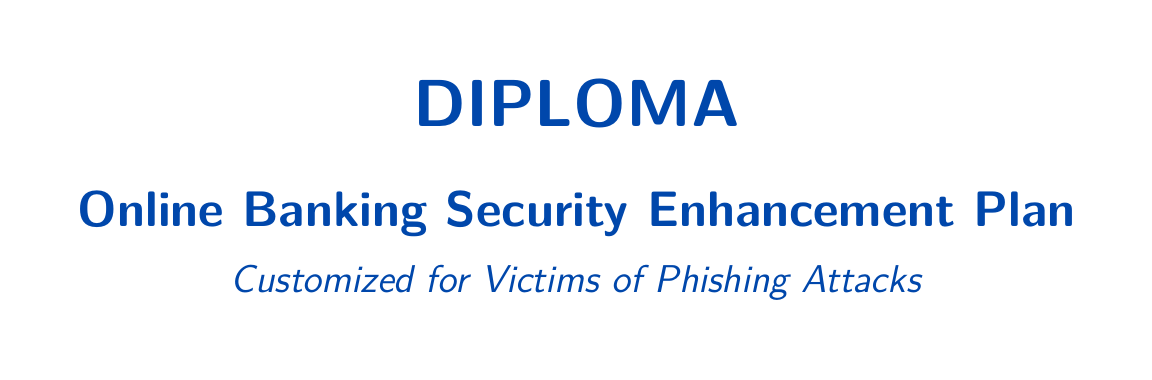What is the title of the document? The title of the document is stated at the top and identifies the content focus.
Answer: Online Banking Security Enhancement Plan What should you do immediately after a phishing incident? The document includes a specific section detailing immediate steps to take post-incident.
Answer: Change your online banking passwords What is one action you can take to enhance online banking security? The document lists several actionable steps to improve security for online banking accounts.
Answer: Enable Two-Factor Authentication (2FA) How often should you monitor your account activity? The document mentions the importance of frequent reviews to detect suspicious transactions.
Answer: Regularly What type of software should you install for protection? The document recommends specific tools to enhance security against potential threats.
Answer: Anti-virus and Anti-Malware Software What is advised regarding emails and links? The document provides guidance on handling unsolicited communications to avoid phishing attacks.
Answer: Be Cautious with Emails and Links What is recommended for backing up important data? The document suggests specific methods for data backup to ensure security.
Answer: Secure, encrypted cloud storage What organization should phishing attempts be reported to? The document recommends notifying specific bodies in case you experience phishing.
Answer: Anti-Phishing Working Group How does this document spread awareness about online banking security? The document is structured to educate victims of phishing on security and best practices.
Answer: By following actionable steps 